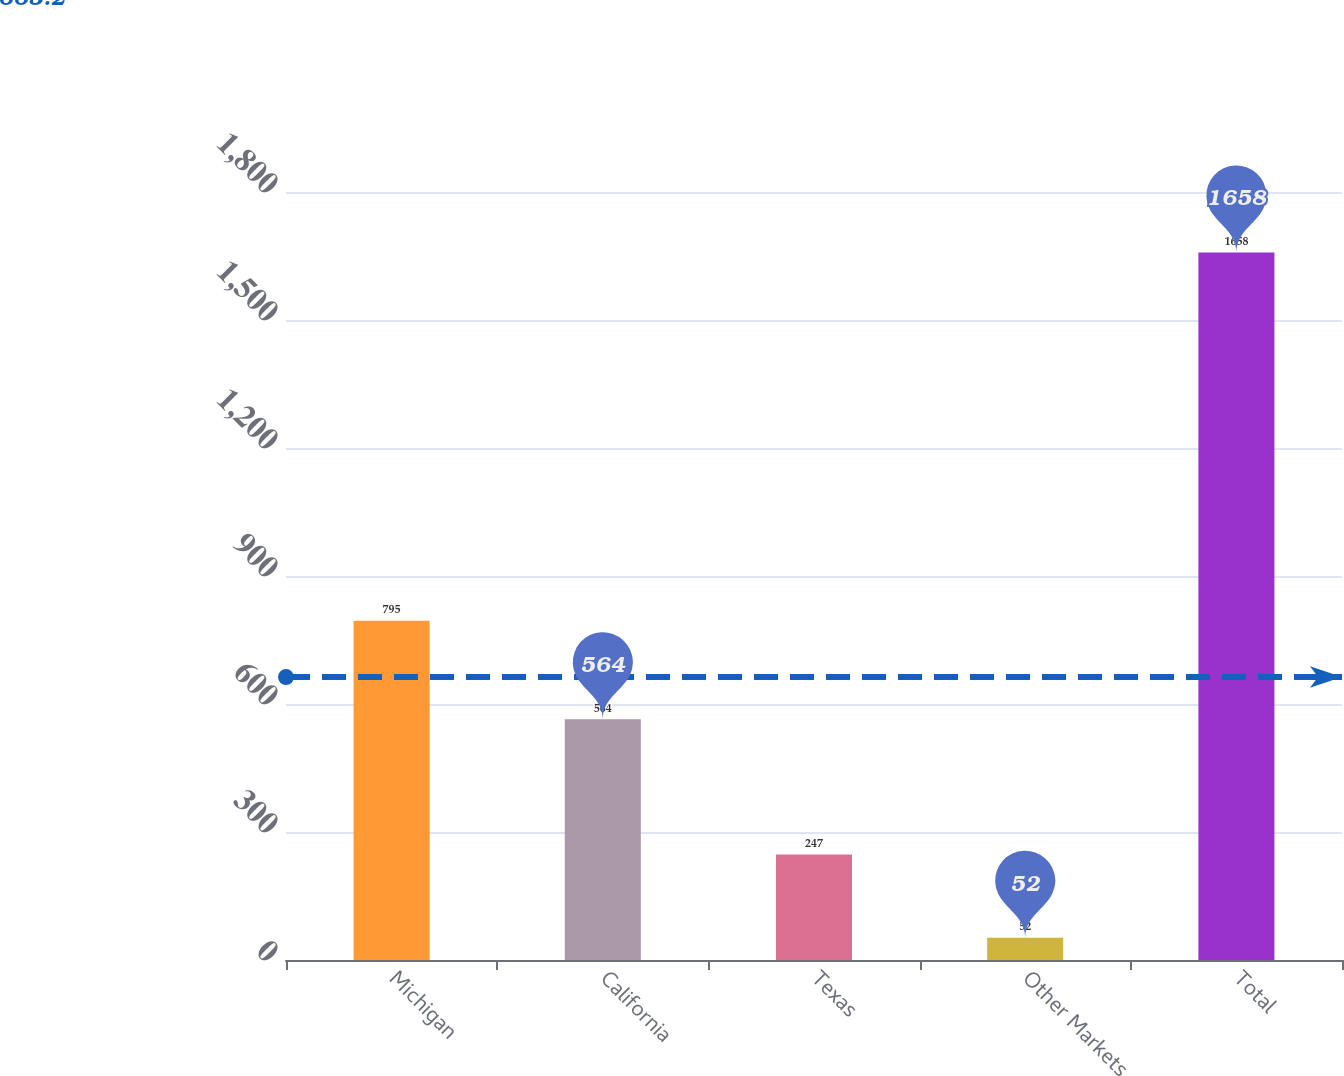Convert chart. <chart><loc_0><loc_0><loc_500><loc_500><bar_chart><fcel>Michigan<fcel>California<fcel>Texas<fcel>Other Markets<fcel>Total<nl><fcel>795<fcel>564<fcel>247<fcel>52<fcel>1658<nl></chart> 